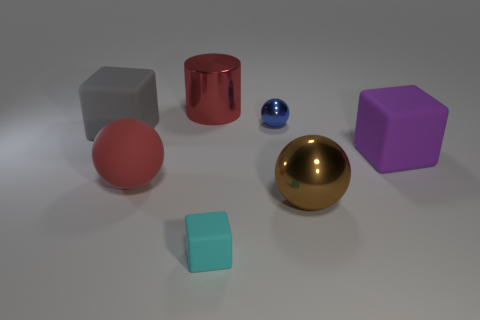Add 3 small cyan matte cylinders. How many objects exist? 10 Subtract all large balls. How many balls are left? 1 Subtract all yellow spheres. Subtract all cyan blocks. How many spheres are left? 3 Subtract all cylinders. How many objects are left? 6 Add 3 large matte cubes. How many large matte cubes exist? 5 Subtract 0 cyan cylinders. How many objects are left? 7 Subtract all red matte spheres. Subtract all large purple rubber cubes. How many objects are left? 5 Add 7 large brown metallic things. How many large brown metallic things are left? 8 